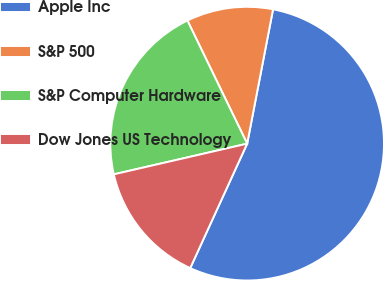Convert chart to OTSL. <chart><loc_0><loc_0><loc_500><loc_500><pie_chart><fcel>Apple Inc<fcel>S&P 500<fcel>S&P Computer Hardware<fcel>Dow Jones US Technology<nl><fcel>53.8%<fcel>10.22%<fcel>21.41%<fcel>14.57%<nl></chart> 